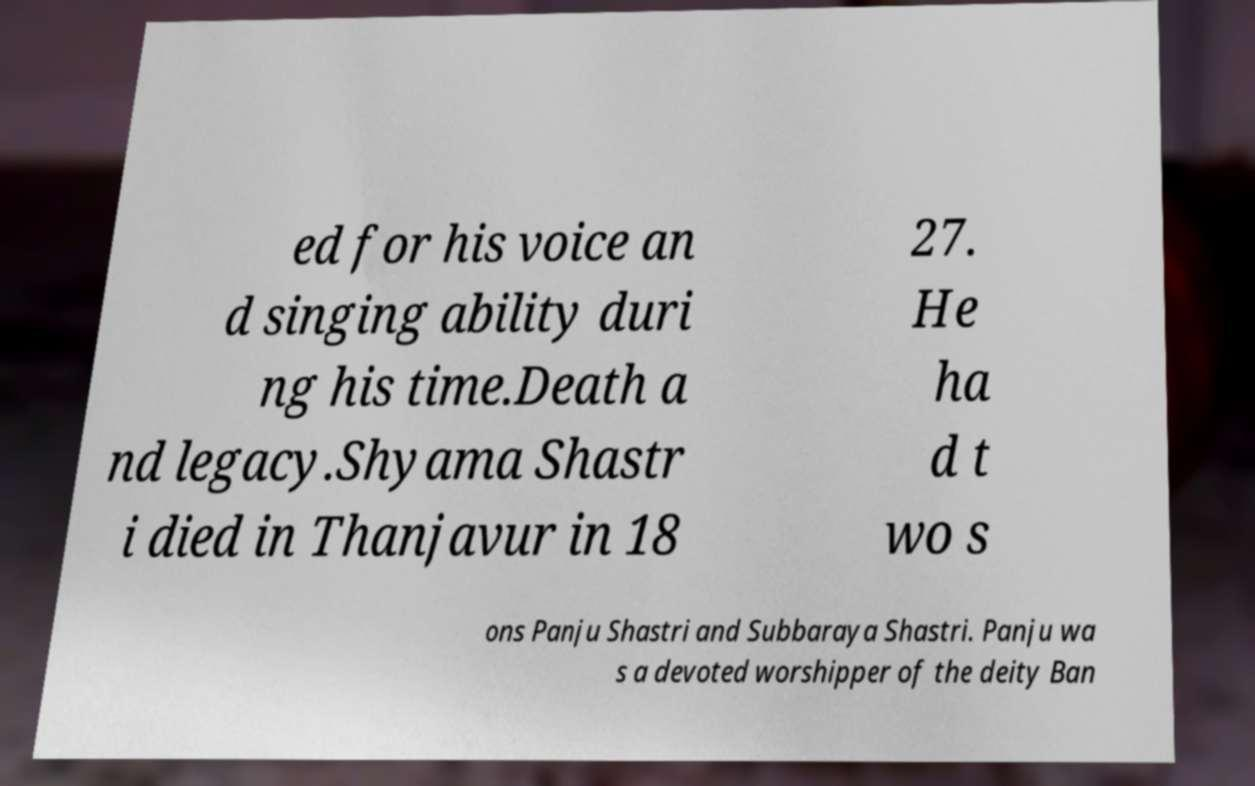Can you read and provide the text displayed in the image?This photo seems to have some interesting text. Can you extract and type it out for me? ed for his voice an d singing ability duri ng his time.Death a nd legacy.Shyama Shastr i died in Thanjavur in 18 27. He ha d t wo s ons Panju Shastri and Subbaraya Shastri. Panju wa s a devoted worshipper of the deity Ban 